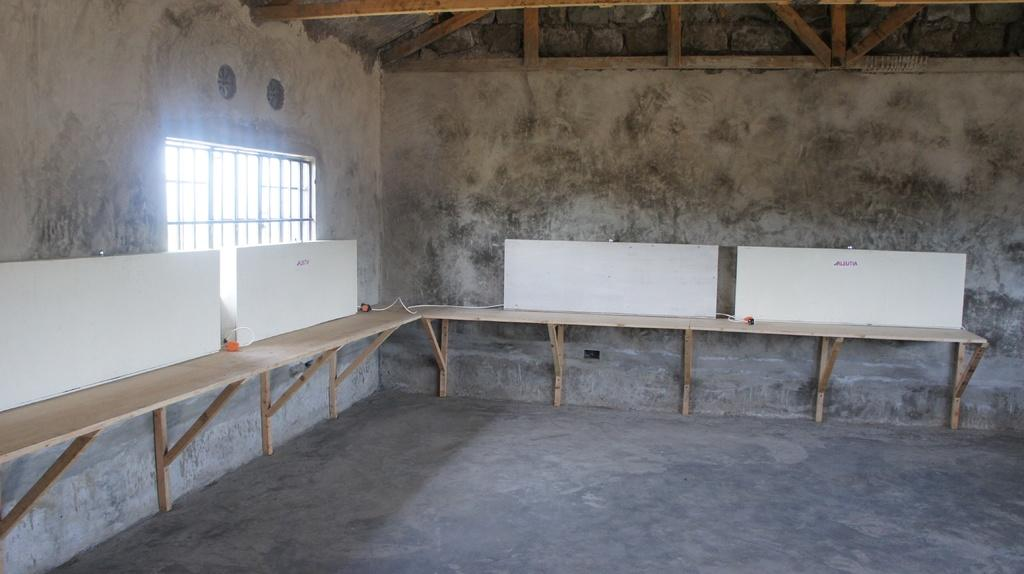What is placed on the wooden table in the image? There are white color boards on a wooden table. What can be seen in the background of the image? There is a window and a wall in the image. What type of trouble can be seen in the image? There is no trouble depicted in the image; it features white color boards on a wooden table, a window, and a wall. What need is being addressed by the presence of the white color boards in the image? The image does not provide information about any specific needs being addressed by the presence of the white color boards. 